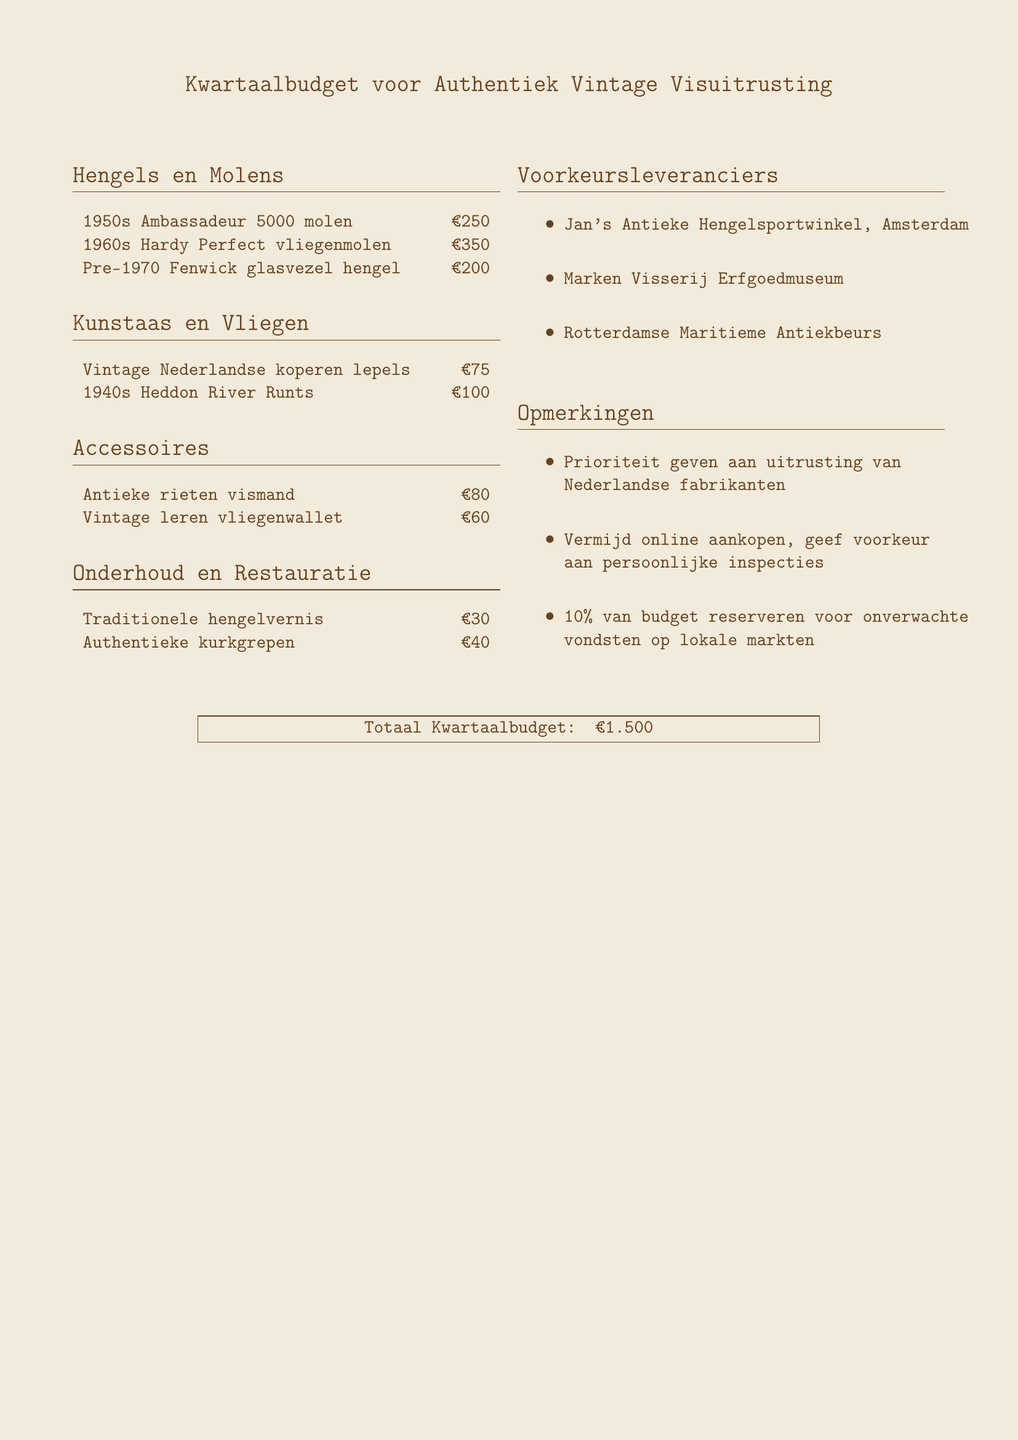Wat is het budget voor authenticiteit? Het totale budget voor authenticiteit is genoemd aan het einde van het document.
Answer: €1.500 Welke antieke rieten vismand kost? De prijs van de antieke rieten vismand is gegeven in het gedeelte "Accessoires".
Answer: €80 Wat voor soort hengel wordt er in de jaren '60 genoemd? De specifieke hengel uit de jaren '60 wordt onder "Hengels en Molens" genoemd.
Answer: Hardy Perfect vliegenmolen Welke leverancier is gevestigd in Amsterdam? De naam van de leverancier die in Amsterdam is gevestigd staat in de sectie "Voorkeursleveranciers".
Answer: Jan's Antieke Hengelsportwinkel Wat is de prijs van de Vintage Nederlandse koperen lepels? De prijs van de Vintage Nederlandse koperen lepels is vermeld in de sectie "Kunstaas en Vliegen".
Answer: €75 Hoeveel procent van het budget is gereserveerd voor onverwachte vondsten? Dit percentage is genoemd in de "Opmerkingen" sectie van het document.
Answer: 10% Wat is de prijs van traditionele hengelvernis? De prijs van traditionele hengelvernis wordt gegeven in de sectie "Onderhoud en Restauratie".
Answer: €30 Noem een voorkeur die voor persoonlijke inspecties is. Een voorkeur die vermeld staat in de "Opmerkingen" sectie van de begroting.
Answer: Vermijd online aankopen 